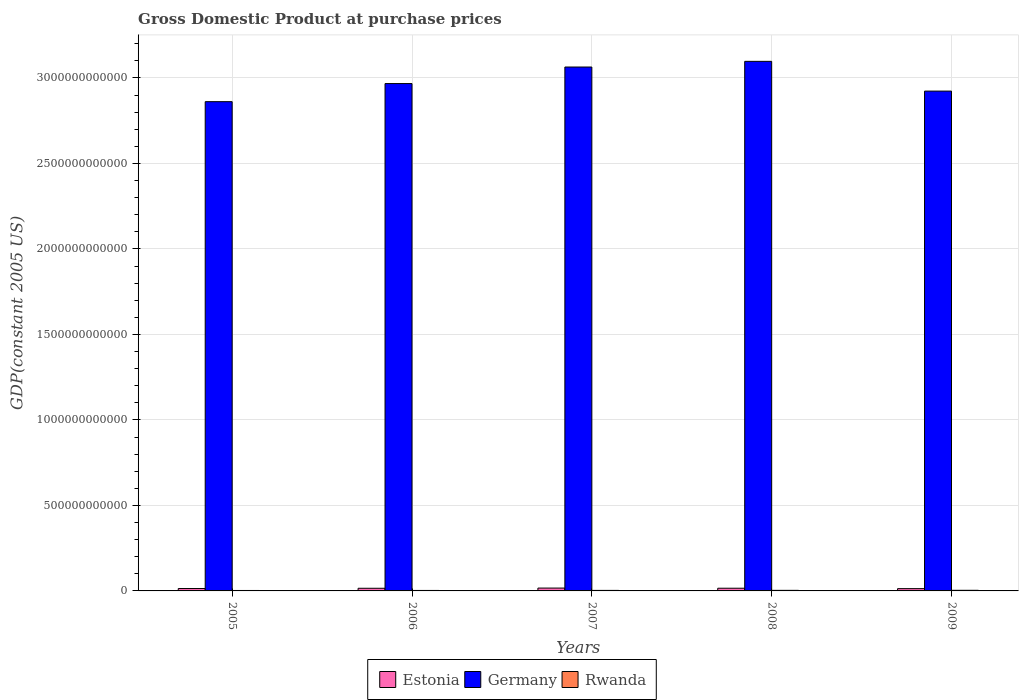How many groups of bars are there?
Give a very brief answer. 5. Are the number of bars on each tick of the X-axis equal?
Offer a terse response. Yes. How many bars are there on the 2nd tick from the left?
Your answer should be very brief. 3. In how many cases, is the number of bars for a given year not equal to the number of legend labels?
Provide a succinct answer. 0. What is the GDP at purchase prices in Germany in 2005?
Make the answer very short. 2.86e+12. Across all years, what is the maximum GDP at purchase prices in Germany?
Your response must be concise. 3.10e+12. Across all years, what is the minimum GDP at purchase prices in Germany?
Your answer should be very brief. 2.86e+12. In which year was the GDP at purchase prices in Rwanda minimum?
Provide a succinct answer. 2005. What is the total GDP at purchase prices in Rwanda in the graph?
Make the answer very short. 1.54e+1. What is the difference between the GDP at purchase prices in Germany in 2005 and that in 2006?
Keep it short and to the point. -1.06e+11. What is the difference between the GDP at purchase prices in Germany in 2009 and the GDP at purchase prices in Rwanda in 2006?
Offer a very short reply. 2.92e+12. What is the average GDP at purchase prices in Germany per year?
Offer a terse response. 2.98e+12. In the year 2009, what is the difference between the GDP at purchase prices in Estonia and GDP at purchase prices in Germany?
Give a very brief answer. -2.91e+12. In how many years, is the GDP at purchase prices in Germany greater than 2600000000000 US$?
Ensure brevity in your answer.  5. What is the ratio of the GDP at purchase prices in Rwanda in 2005 to that in 2009?
Ensure brevity in your answer.  0.72. Is the GDP at purchase prices in Germany in 2007 less than that in 2008?
Make the answer very short. Yes. What is the difference between the highest and the second highest GDP at purchase prices in Germany?
Make the answer very short. 3.32e+1. What is the difference between the highest and the lowest GDP at purchase prices in Estonia?
Offer a terse response. 3.22e+09. What does the 3rd bar from the left in 2005 represents?
Your answer should be very brief. Rwanda. What does the 1st bar from the right in 2006 represents?
Keep it short and to the point. Rwanda. Is it the case that in every year, the sum of the GDP at purchase prices in Rwanda and GDP at purchase prices in Estonia is greater than the GDP at purchase prices in Germany?
Your response must be concise. No. How many bars are there?
Give a very brief answer. 15. How many years are there in the graph?
Provide a succinct answer. 5. What is the difference between two consecutive major ticks on the Y-axis?
Your answer should be very brief. 5.00e+11. Does the graph contain any zero values?
Ensure brevity in your answer.  No. Does the graph contain grids?
Make the answer very short. Yes. Where does the legend appear in the graph?
Offer a terse response. Bottom center. How many legend labels are there?
Offer a terse response. 3. What is the title of the graph?
Your answer should be very brief. Gross Domestic Product at purchase prices. What is the label or title of the X-axis?
Ensure brevity in your answer.  Years. What is the label or title of the Y-axis?
Make the answer very short. GDP(constant 2005 US). What is the GDP(constant 2005 US) of Estonia in 2005?
Offer a very short reply. 1.40e+1. What is the GDP(constant 2005 US) of Germany in 2005?
Provide a short and direct response. 2.86e+12. What is the GDP(constant 2005 US) of Rwanda in 2005?
Your answer should be very brief. 2.58e+09. What is the GDP(constant 2005 US) in Estonia in 2006?
Provide a short and direct response. 1.54e+1. What is the GDP(constant 2005 US) in Germany in 2006?
Your answer should be very brief. 2.97e+12. What is the GDP(constant 2005 US) in Rwanda in 2006?
Give a very brief answer. 2.82e+09. What is the GDP(constant 2005 US) in Estonia in 2007?
Your answer should be compact. 1.66e+1. What is the GDP(constant 2005 US) of Germany in 2007?
Make the answer very short. 3.06e+12. What is the GDP(constant 2005 US) in Rwanda in 2007?
Your answer should be compact. 3.03e+09. What is the GDP(constant 2005 US) in Estonia in 2008?
Make the answer very short. 1.57e+1. What is the GDP(constant 2005 US) in Germany in 2008?
Provide a succinct answer. 3.10e+12. What is the GDP(constant 2005 US) in Rwanda in 2008?
Offer a very short reply. 3.37e+09. What is the GDP(constant 2005 US) of Estonia in 2009?
Your answer should be compact. 1.34e+1. What is the GDP(constant 2005 US) in Germany in 2009?
Provide a succinct answer. 2.92e+12. What is the GDP(constant 2005 US) of Rwanda in 2009?
Your answer should be very brief. 3.58e+09. Across all years, what is the maximum GDP(constant 2005 US) of Estonia?
Provide a short and direct response. 1.66e+1. Across all years, what is the maximum GDP(constant 2005 US) in Germany?
Your response must be concise. 3.10e+12. Across all years, what is the maximum GDP(constant 2005 US) of Rwanda?
Offer a terse response. 3.58e+09. Across all years, what is the minimum GDP(constant 2005 US) in Estonia?
Your answer should be very brief. 1.34e+1. Across all years, what is the minimum GDP(constant 2005 US) in Germany?
Give a very brief answer. 2.86e+12. Across all years, what is the minimum GDP(constant 2005 US) in Rwanda?
Ensure brevity in your answer.  2.58e+09. What is the total GDP(constant 2005 US) of Estonia in the graph?
Ensure brevity in your answer.  7.53e+1. What is the total GDP(constant 2005 US) in Germany in the graph?
Provide a short and direct response. 1.49e+13. What is the total GDP(constant 2005 US) of Rwanda in the graph?
Provide a succinct answer. 1.54e+1. What is the difference between the GDP(constant 2005 US) in Estonia in 2005 and that in 2006?
Provide a succinct answer. -1.44e+09. What is the difference between the GDP(constant 2005 US) in Germany in 2005 and that in 2006?
Your answer should be compact. -1.06e+11. What is the difference between the GDP(constant 2005 US) of Rwanda in 2005 and that in 2006?
Offer a terse response. -2.38e+08. What is the difference between the GDP(constant 2005 US) in Estonia in 2005 and that in 2007?
Provide a short and direct response. -2.64e+09. What is the difference between the GDP(constant 2005 US) in Germany in 2005 and that in 2007?
Make the answer very short. -2.03e+11. What is the difference between the GDP(constant 2005 US) in Rwanda in 2005 and that in 2007?
Your answer should be very brief. -4.53e+08. What is the difference between the GDP(constant 2005 US) of Estonia in 2005 and that in 2008?
Offer a terse response. -1.73e+09. What is the difference between the GDP(constant 2005 US) in Germany in 2005 and that in 2008?
Provide a succinct answer. -2.36e+11. What is the difference between the GDP(constant 2005 US) of Rwanda in 2005 and that in 2008?
Your answer should be very brief. -7.92e+08. What is the difference between the GDP(constant 2005 US) in Estonia in 2005 and that in 2009?
Keep it short and to the point. 5.84e+08. What is the difference between the GDP(constant 2005 US) in Germany in 2005 and that in 2009?
Your answer should be very brief. -6.18e+1. What is the difference between the GDP(constant 2005 US) of Rwanda in 2005 and that in 2009?
Your answer should be compact. -1.00e+09. What is the difference between the GDP(constant 2005 US) of Estonia in 2006 and that in 2007?
Provide a short and direct response. -1.20e+09. What is the difference between the GDP(constant 2005 US) of Germany in 2006 and that in 2007?
Ensure brevity in your answer.  -9.67e+1. What is the difference between the GDP(constant 2005 US) in Rwanda in 2006 and that in 2007?
Your answer should be compact. -2.15e+08. What is the difference between the GDP(constant 2005 US) of Estonia in 2006 and that in 2008?
Provide a succinct answer. -2.95e+08. What is the difference between the GDP(constant 2005 US) in Germany in 2006 and that in 2008?
Offer a very short reply. -1.30e+11. What is the difference between the GDP(constant 2005 US) of Rwanda in 2006 and that in 2008?
Your answer should be compact. -5.53e+08. What is the difference between the GDP(constant 2005 US) of Estonia in 2006 and that in 2009?
Your answer should be compact. 2.02e+09. What is the difference between the GDP(constant 2005 US) in Germany in 2006 and that in 2009?
Offer a terse response. 4.41e+1. What is the difference between the GDP(constant 2005 US) in Rwanda in 2006 and that in 2009?
Your answer should be very brief. -7.65e+08. What is the difference between the GDP(constant 2005 US) in Estonia in 2007 and that in 2008?
Keep it short and to the point. 9.02e+08. What is the difference between the GDP(constant 2005 US) in Germany in 2007 and that in 2008?
Offer a very short reply. -3.32e+1. What is the difference between the GDP(constant 2005 US) of Rwanda in 2007 and that in 2008?
Offer a terse response. -3.39e+08. What is the difference between the GDP(constant 2005 US) of Estonia in 2007 and that in 2009?
Offer a terse response. 3.22e+09. What is the difference between the GDP(constant 2005 US) of Germany in 2007 and that in 2009?
Your response must be concise. 1.41e+11. What is the difference between the GDP(constant 2005 US) in Rwanda in 2007 and that in 2009?
Provide a short and direct response. -5.50e+08. What is the difference between the GDP(constant 2005 US) in Estonia in 2008 and that in 2009?
Your answer should be very brief. 2.32e+09. What is the difference between the GDP(constant 2005 US) of Germany in 2008 and that in 2009?
Keep it short and to the point. 1.74e+11. What is the difference between the GDP(constant 2005 US) in Rwanda in 2008 and that in 2009?
Provide a short and direct response. -2.11e+08. What is the difference between the GDP(constant 2005 US) of Estonia in 2005 and the GDP(constant 2005 US) of Germany in 2006?
Provide a succinct answer. -2.95e+12. What is the difference between the GDP(constant 2005 US) of Estonia in 2005 and the GDP(constant 2005 US) of Rwanda in 2006?
Ensure brevity in your answer.  1.12e+1. What is the difference between the GDP(constant 2005 US) of Germany in 2005 and the GDP(constant 2005 US) of Rwanda in 2006?
Ensure brevity in your answer.  2.86e+12. What is the difference between the GDP(constant 2005 US) in Estonia in 2005 and the GDP(constant 2005 US) in Germany in 2007?
Keep it short and to the point. -3.05e+12. What is the difference between the GDP(constant 2005 US) of Estonia in 2005 and the GDP(constant 2005 US) of Rwanda in 2007?
Ensure brevity in your answer.  1.10e+1. What is the difference between the GDP(constant 2005 US) of Germany in 2005 and the GDP(constant 2005 US) of Rwanda in 2007?
Keep it short and to the point. 2.86e+12. What is the difference between the GDP(constant 2005 US) in Estonia in 2005 and the GDP(constant 2005 US) in Germany in 2008?
Give a very brief answer. -3.08e+12. What is the difference between the GDP(constant 2005 US) in Estonia in 2005 and the GDP(constant 2005 US) in Rwanda in 2008?
Keep it short and to the point. 1.06e+1. What is the difference between the GDP(constant 2005 US) of Germany in 2005 and the GDP(constant 2005 US) of Rwanda in 2008?
Offer a very short reply. 2.86e+12. What is the difference between the GDP(constant 2005 US) of Estonia in 2005 and the GDP(constant 2005 US) of Germany in 2009?
Offer a very short reply. -2.91e+12. What is the difference between the GDP(constant 2005 US) in Estonia in 2005 and the GDP(constant 2005 US) in Rwanda in 2009?
Provide a succinct answer. 1.04e+1. What is the difference between the GDP(constant 2005 US) of Germany in 2005 and the GDP(constant 2005 US) of Rwanda in 2009?
Offer a very short reply. 2.86e+12. What is the difference between the GDP(constant 2005 US) in Estonia in 2006 and the GDP(constant 2005 US) in Germany in 2007?
Provide a short and direct response. -3.05e+12. What is the difference between the GDP(constant 2005 US) of Estonia in 2006 and the GDP(constant 2005 US) of Rwanda in 2007?
Your response must be concise. 1.24e+1. What is the difference between the GDP(constant 2005 US) of Germany in 2006 and the GDP(constant 2005 US) of Rwanda in 2007?
Give a very brief answer. 2.96e+12. What is the difference between the GDP(constant 2005 US) in Estonia in 2006 and the GDP(constant 2005 US) in Germany in 2008?
Provide a succinct answer. -3.08e+12. What is the difference between the GDP(constant 2005 US) of Estonia in 2006 and the GDP(constant 2005 US) of Rwanda in 2008?
Provide a succinct answer. 1.21e+1. What is the difference between the GDP(constant 2005 US) in Germany in 2006 and the GDP(constant 2005 US) in Rwanda in 2008?
Offer a very short reply. 2.96e+12. What is the difference between the GDP(constant 2005 US) of Estonia in 2006 and the GDP(constant 2005 US) of Germany in 2009?
Your answer should be compact. -2.91e+12. What is the difference between the GDP(constant 2005 US) of Estonia in 2006 and the GDP(constant 2005 US) of Rwanda in 2009?
Offer a terse response. 1.19e+1. What is the difference between the GDP(constant 2005 US) of Germany in 2006 and the GDP(constant 2005 US) of Rwanda in 2009?
Your response must be concise. 2.96e+12. What is the difference between the GDP(constant 2005 US) of Estonia in 2007 and the GDP(constant 2005 US) of Germany in 2008?
Keep it short and to the point. -3.08e+12. What is the difference between the GDP(constant 2005 US) in Estonia in 2007 and the GDP(constant 2005 US) in Rwanda in 2008?
Keep it short and to the point. 1.33e+1. What is the difference between the GDP(constant 2005 US) in Germany in 2007 and the GDP(constant 2005 US) in Rwanda in 2008?
Keep it short and to the point. 3.06e+12. What is the difference between the GDP(constant 2005 US) in Estonia in 2007 and the GDP(constant 2005 US) in Germany in 2009?
Provide a succinct answer. -2.91e+12. What is the difference between the GDP(constant 2005 US) in Estonia in 2007 and the GDP(constant 2005 US) in Rwanda in 2009?
Your response must be concise. 1.31e+1. What is the difference between the GDP(constant 2005 US) in Germany in 2007 and the GDP(constant 2005 US) in Rwanda in 2009?
Your response must be concise. 3.06e+12. What is the difference between the GDP(constant 2005 US) of Estonia in 2008 and the GDP(constant 2005 US) of Germany in 2009?
Offer a terse response. -2.91e+12. What is the difference between the GDP(constant 2005 US) in Estonia in 2008 and the GDP(constant 2005 US) in Rwanda in 2009?
Provide a short and direct response. 1.22e+1. What is the difference between the GDP(constant 2005 US) of Germany in 2008 and the GDP(constant 2005 US) of Rwanda in 2009?
Your answer should be compact. 3.09e+12. What is the average GDP(constant 2005 US) in Estonia per year?
Provide a short and direct response. 1.51e+1. What is the average GDP(constant 2005 US) of Germany per year?
Provide a short and direct response. 2.98e+12. What is the average GDP(constant 2005 US) of Rwanda per year?
Give a very brief answer. 3.08e+09. In the year 2005, what is the difference between the GDP(constant 2005 US) in Estonia and GDP(constant 2005 US) in Germany?
Offer a terse response. -2.85e+12. In the year 2005, what is the difference between the GDP(constant 2005 US) in Estonia and GDP(constant 2005 US) in Rwanda?
Offer a terse response. 1.14e+1. In the year 2005, what is the difference between the GDP(constant 2005 US) of Germany and GDP(constant 2005 US) of Rwanda?
Provide a succinct answer. 2.86e+12. In the year 2006, what is the difference between the GDP(constant 2005 US) in Estonia and GDP(constant 2005 US) in Germany?
Give a very brief answer. -2.95e+12. In the year 2006, what is the difference between the GDP(constant 2005 US) of Estonia and GDP(constant 2005 US) of Rwanda?
Your response must be concise. 1.26e+1. In the year 2006, what is the difference between the GDP(constant 2005 US) of Germany and GDP(constant 2005 US) of Rwanda?
Give a very brief answer. 2.96e+12. In the year 2007, what is the difference between the GDP(constant 2005 US) in Estonia and GDP(constant 2005 US) in Germany?
Make the answer very short. -3.05e+12. In the year 2007, what is the difference between the GDP(constant 2005 US) in Estonia and GDP(constant 2005 US) in Rwanda?
Your answer should be compact. 1.36e+1. In the year 2007, what is the difference between the GDP(constant 2005 US) of Germany and GDP(constant 2005 US) of Rwanda?
Your answer should be compact. 3.06e+12. In the year 2008, what is the difference between the GDP(constant 2005 US) in Estonia and GDP(constant 2005 US) in Germany?
Keep it short and to the point. -3.08e+12. In the year 2008, what is the difference between the GDP(constant 2005 US) in Estonia and GDP(constant 2005 US) in Rwanda?
Make the answer very short. 1.24e+1. In the year 2008, what is the difference between the GDP(constant 2005 US) in Germany and GDP(constant 2005 US) in Rwanda?
Your answer should be compact. 3.09e+12. In the year 2009, what is the difference between the GDP(constant 2005 US) in Estonia and GDP(constant 2005 US) in Germany?
Offer a very short reply. -2.91e+12. In the year 2009, what is the difference between the GDP(constant 2005 US) of Estonia and GDP(constant 2005 US) of Rwanda?
Offer a terse response. 9.84e+09. In the year 2009, what is the difference between the GDP(constant 2005 US) in Germany and GDP(constant 2005 US) in Rwanda?
Your answer should be compact. 2.92e+12. What is the ratio of the GDP(constant 2005 US) of Estonia in 2005 to that in 2006?
Provide a succinct answer. 0.91. What is the ratio of the GDP(constant 2005 US) in Rwanda in 2005 to that in 2006?
Your answer should be compact. 0.92. What is the ratio of the GDP(constant 2005 US) in Estonia in 2005 to that in 2007?
Ensure brevity in your answer.  0.84. What is the ratio of the GDP(constant 2005 US) of Germany in 2005 to that in 2007?
Make the answer very short. 0.93. What is the ratio of the GDP(constant 2005 US) in Rwanda in 2005 to that in 2007?
Make the answer very short. 0.85. What is the ratio of the GDP(constant 2005 US) of Estonia in 2005 to that in 2008?
Make the answer very short. 0.89. What is the ratio of the GDP(constant 2005 US) in Germany in 2005 to that in 2008?
Make the answer very short. 0.92. What is the ratio of the GDP(constant 2005 US) of Rwanda in 2005 to that in 2008?
Keep it short and to the point. 0.77. What is the ratio of the GDP(constant 2005 US) in Estonia in 2005 to that in 2009?
Offer a terse response. 1.04. What is the ratio of the GDP(constant 2005 US) in Germany in 2005 to that in 2009?
Your answer should be very brief. 0.98. What is the ratio of the GDP(constant 2005 US) in Rwanda in 2005 to that in 2009?
Offer a very short reply. 0.72. What is the ratio of the GDP(constant 2005 US) in Estonia in 2006 to that in 2007?
Give a very brief answer. 0.93. What is the ratio of the GDP(constant 2005 US) of Germany in 2006 to that in 2007?
Offer a very short reply. 0.97. What is the ratio of the GDP(constant 2005 US) of Rwanda in 2006 to that in 2007?
Make the answer very short. 0.93. What is the ratio of the GDP(constant 2005 US) in Estonia in 2006 to that in 2008?
Provide a short and direct response. 0.98. What is the ratio of the GDP(constant 2005 US) of Germany in 2006 to that in 2008?
Your response must be concise. 0.96. What is the ratio of the GDP(constant 2005 US) in Rwanda in 2006 to that in 2008?
Your response must be concise. 0.84. What is the ratio of the GDP(constant 2005 US) in Estonia in 2006 to that in 2009?
Your answer should be very brief. 1.15. What is the ratio of the GDP(constant 2005 US) in Germany in 2006 to that in 2009?
Give a very brief answer. 1.02. What is the ratio of the GDP(constant 2005 US) in Rwanda in 2006 to that in 2009?
Keep it short and to the point. 0.79. What is the ratio of the GDP(constant 2005 US) in Estonia in 2007 to that in 2008?
Give a very brief answer. 1.06. What is the ratio of the GDP(constant 2005 US) of Germany in 2007 to that in 2008?
Your answer should be compact. 0.99. What is the ratio of the GDP(constant 2005 US) of Rwanda in 2007 to that in 2008?
Provide a succinct answer. 0.9. What is the ratio of the GDP(constant 2005 US) of Estonia in 2007 to that in 2009?
Offer a terse response. 1.24. What is the ratio of the GDP(constant 2005 US) in Germany in 2007 to that in 2009?
Offer a terse response. 1.05. What is the ratio of the GDP(constant 2005 US) in Rwanda in 2007 to that in 2009?
Offer a very short reply. 0.85. What is the ratio of the GDP(constant 2005 US) of Estonia in 2008 to that in 2009?
Ensure brevity in your answer.  1.17. What is the ratio of the GDP(constant 2005 US) of Germany in 2008 to that in 2009?
Ensure brevity in your answer.  1.06. What is the ratio of the GDP(constant 2005 US) in Rwanda in 2008 to that in 2009?
Your answer should be compact. 0.94. What is the difference between the highest and the second highest GDP(constant 2005 US) of Estonia?
Make the answer very short. 9.02e+08. What is the difference between the highest and the second highest GDP(constant 2005 US) in Germany?
Ensure brevity in your answer.  3.32e+1. What is the difference between the highest and the second highest GDP(constant 2005 US) in Rwanda?
Keep it short and to the point. 2.11e+08. What is the difference between the highest and the lowest GDP(constant 2005 US) of Estonia?
Your response must be concise. 3.22e+09. What is the difference between the highest and the lowest GDP(constant 2005 US) of Germany?
Offer a terse response. 2.36e+11. What is the difference between the highest and the lowest GDP(constant 2005 US) of Rwanda?
Offer a terse response. 1.00e+09. 